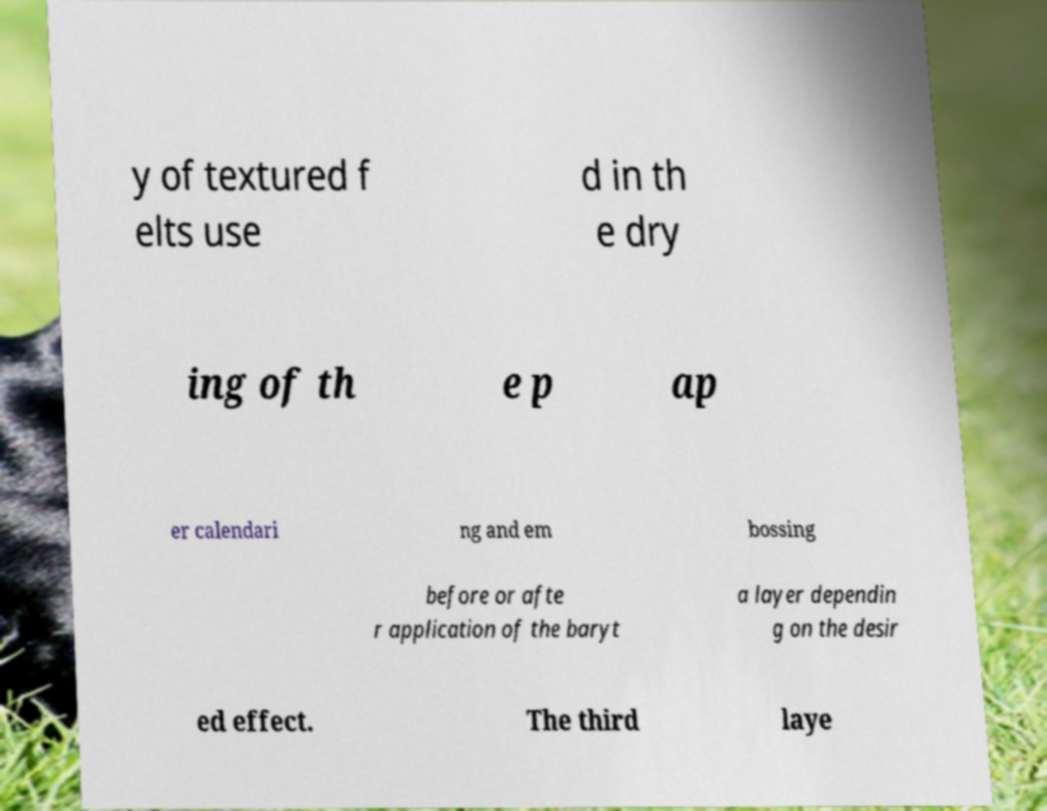Please identify and transcribe the text found in this image. y of textured f elts use d in th e dry ing of th e p ap er calendari ng and em bossing before or afte r application of the baryt a layer dependin g on the desir ed effect. The third laye 